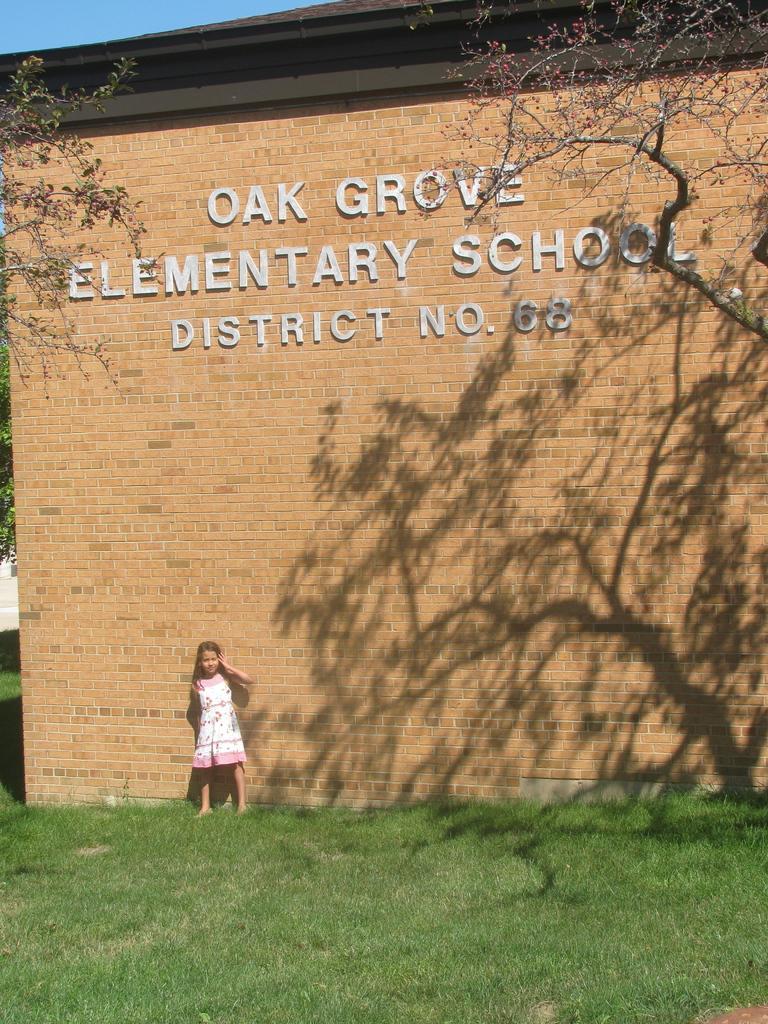Please provide a concise description of this image. In this image there is a wall in the middle. In front of the wall there is a girl. At the bottom there is grass. There are trees on either side of the wall. On the wall there is some text. 